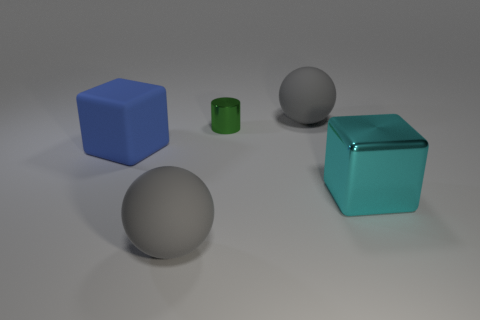Add 1 green metallic things. How many objects exist? 6 Subtract all balls. How many objects are left? 3 Add 1 small green metallic cylinders. How many small green metallic cylinders exist? 2 Subtract 0 yellow balls. How many objects are left? 5 Subtract all yellow cubes. Subtract all big gray matte objects. How many objects are left? 3 Add 3 metal cylinders. How many metal cylinders are left? 4 